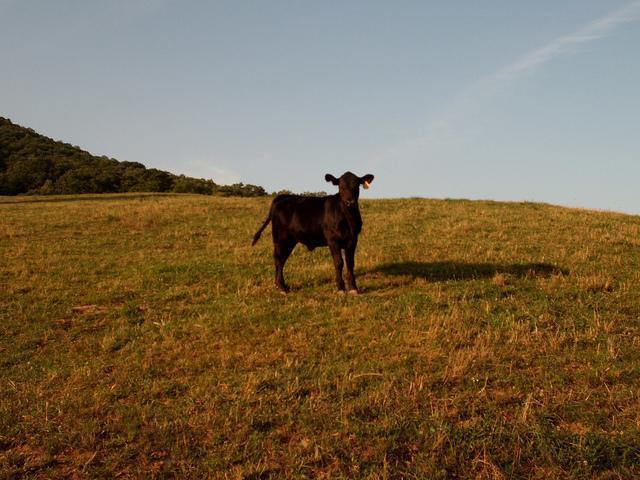How many cows?
Give a very brief answer. 1. How many animals are in the photo?
Give a very brief answer. 1. How many animals are pictured?
Give a very brief answer. 1. How many horses are there?
Give a very brief answer. 0. How many people are not wearing glasses?
Give a very brief answer. 0. 